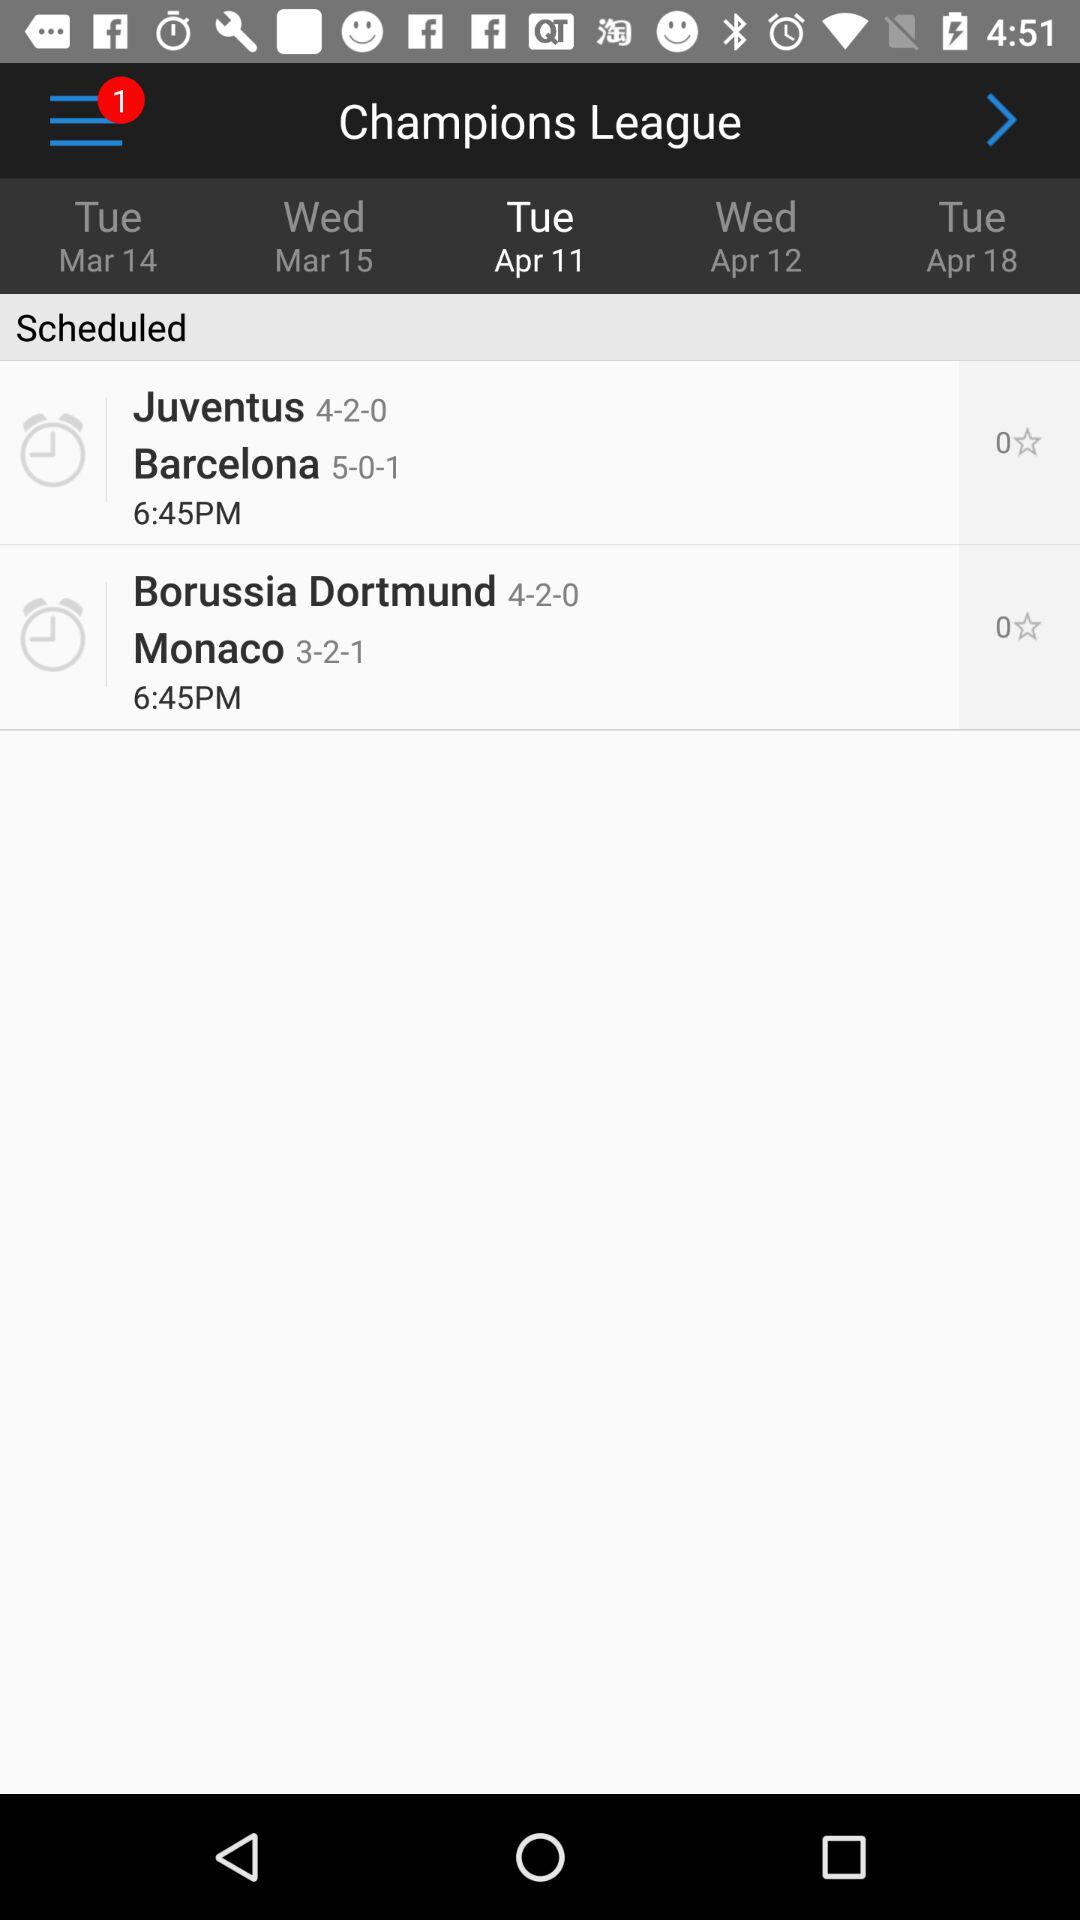On which tab am I now? You are now on the tab "Tue Apr 11". 